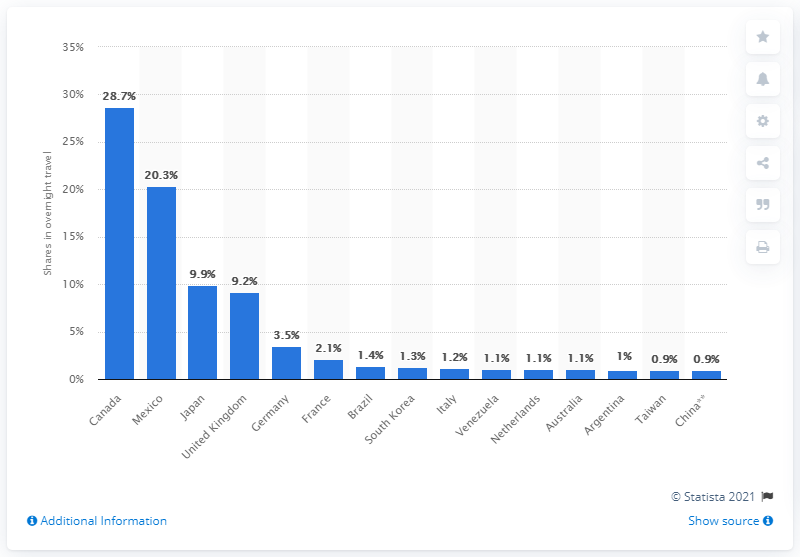Draw attention to some important aspects in this diagram. According to the data, 9.9% of the overnight travelers who stayed in the city came from Japan. 